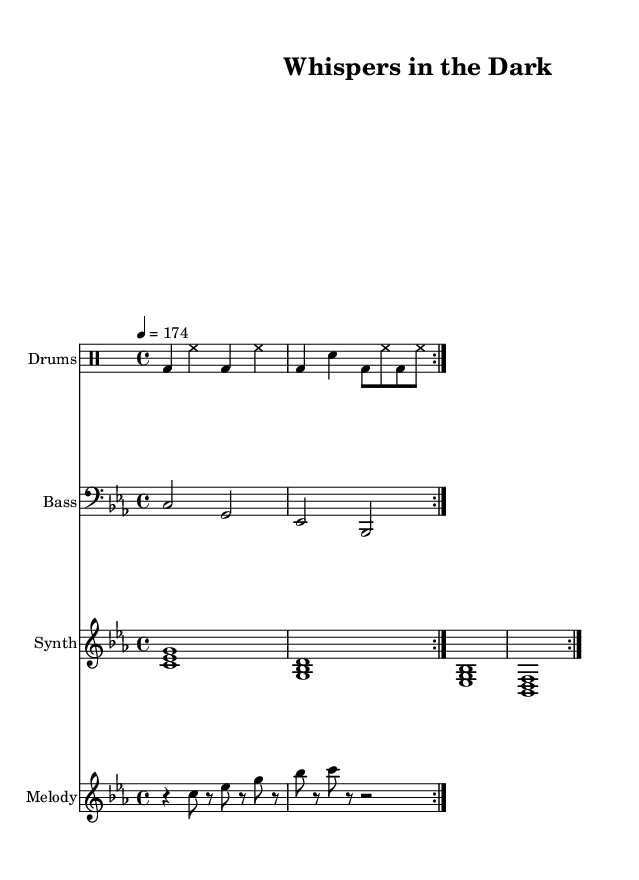What is the key signature of this music? The key signature is indicated at the beginning of the score, showing no sharps or flats, which identifies it as C minor.
Answer: C minor What is the time signature of this piece? The time signature is found at the beginning of the score, where it shows a 4/4 time signature, indicating four beats per measure.
Answer: 4/4 What is the tempo marking for this composition? The tempo indication, located above the staff, states that the piece should be played at a speed of 174 beats per minute.
Answer: 174 How many times is the drum pattern repeated? The drum part contains a repeat directive, specifically stating to repeat the section two times.
Answer: 2 What is the highest note in the melody part? By analyzing the melody part, the highest note is G, which is notated in the second measure of the section.
Answer: G What type of instrument is in the synth part? The synth part is labeled as a "PianoStaff," indicating that the synthesized sounds are to be played on a piano instrument.
Answer: Synth Which mode does the bass part predominantly utilize? Upon examining the bass notes, it follows a pattern moving between C and G, which is characteristic of a minor mode, specifically the C minor scale.
Answer: Minor 